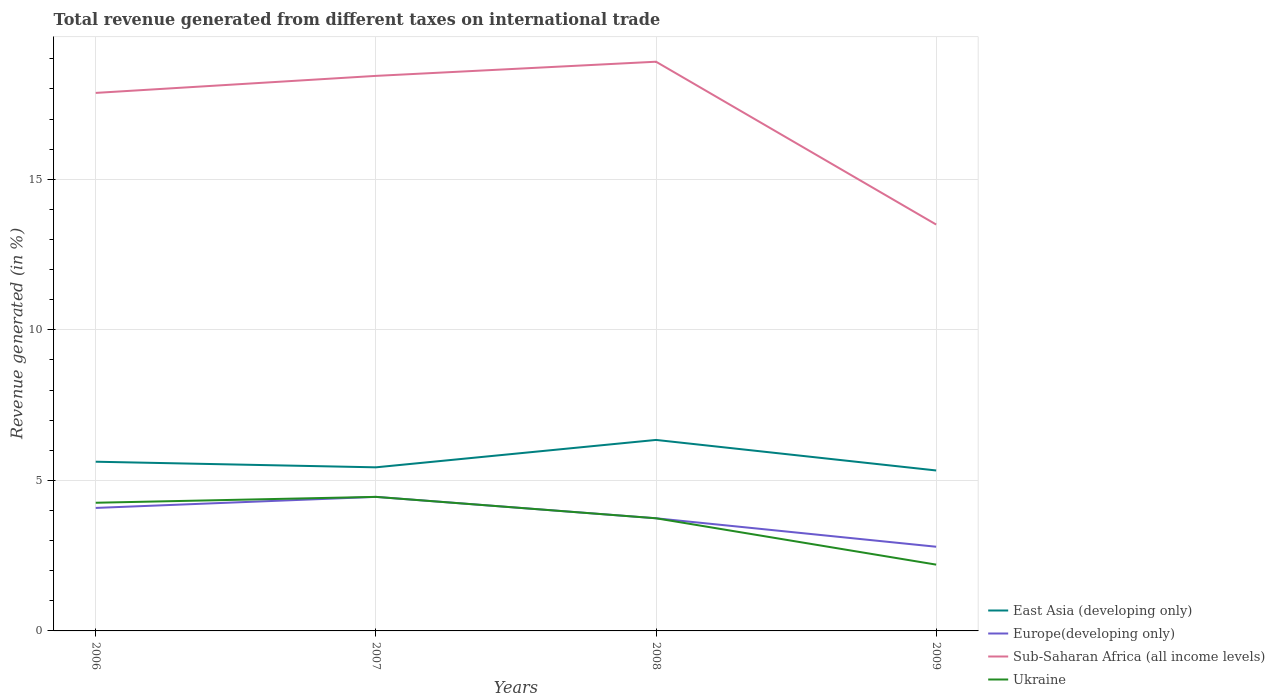Does the line corresponding to Europe(developing only) intersect with the line corresponding to Sub-Saharan Africa (all income levels)?
Ensure brevity in your answer.  No. Is the number of lines equal to the number of legend labels?
Your answer should be very brief. Yes. Across all years, what is the maximum total revenue generated in Ukraine?
Provide a short and direct response. 2.2. In which year was the total revenue generated in Europe(developing only) maximum?
Ensure brevity in your answer.  2009. What is the total total revenue generated in East Asia (developing only) in the graph?
Your response must be concise. 0.19. What is the difference between the highest and the second highest total revenue generated in Sub-Saharan Africa (all income levels)?
Ensure brevity in your answer.  5.41. What is the difference between the highest and the lowest total revenue generated in Ukraine?
Ensure brevity in your answer.  3. Is the total revenue generated in Sub-Saharan Africa (all income levels) strictly greater than the total revenue generated in East Asia (developing only) over the years?
Make the answer very short. No. Does the graph contain grids?
Give a very brief answer. Yes. How many legend labels are there?
Provide a succinct answer. 4. How are the legend labels stacked?
Offer a terse response. Vertical. What is the title of the graph?
Provide a short and direct response. Total revenue generated from different taxes on international trade. What is the label or title of the X-axis?
Keep it short and to the point. Years. What is the label or title of the Y-axis?
Offer a terse response. Revenue generated (in %). What is the Revenue generated (in %) of East Asia (developing only) in 2006?
Your answer should be very brief. 5.62. What is the Revenue generated (in %) of Europe(developing only) in 2006?
Provide a short and direct response. 4.08. What is the Revenue generated (in %) in Sub-Saharan Africa (all income levels) in 2006?
Ensure brevity in your answer.  17.87. What is the Revenue generated (in %) in Ukraine in 2006?
Offer a terse response. 4.26. What is the Revenue generated (in %) in East Asia (developing only) in 2007?
Ensure brevity in your answer.  5.43. What is the Revenue generated (in %) of Europe(developing only) in 2007?
Keep it short and to the point. 4.45. What is the Revenue generated (in %) of Sub-Saharan Africa (all income levels) in 2007?
Your response must be concise. 18.43. What is the Revenue generated (in %) of Ukraine in 2007?
Give a very brief answer. 4.45. What is the Revenue generated (in %) in East Asia (developing only) in 2008?
Make the answer very short. 6.34. What is the Revenue generated (in %) of Europe(developing only) in 2008?
Give a very brief answer. 3.74. What is the Revenue generated (in %) of Sub-Saharan Africa (all income levels) in 2008?
Keep it short and to the point. 18.9. What is the Revenue generated (in %) in Ukraine in 2008?
Offer a terse response. 3.74. What is the Revenue generated (in %) in East Asia (developing only) in 2009?
Provide a short and direct response. 5.33. What is the Revenue generated (in %) of Europe(developing only) in 2009?
Your answer should be compact. 2.8. What is the Revenue generated (in %) in Sub-Saharan Africa (all income levels) in 2009?
Keep it short and to the point. 13.5. What is the Revenue generated (in %) of Ukraine in 2009?
Your response must be concise. 2.2. Across all years, what is the maximum Revenue generated (in %) of East Asia (developing only)?
Ensure brevity in your answer.  6.34. Across all years, what is the maximum Revenue generated (in %) of Europe(developing only)?
Offer a terse response. 4.45. Across all years, what is the maximum Revenue generated (in %) of Sub-Saharan Africa (all income levels)?
Make the answer very short. 18.9. Across all years, what is the maximum Revenue generated (in %) of Ukraine?
Your answer should be very brief. 4.45. Across all years, what is the minimum Revenue generated (in %) in East Asia (developing only)?
Ensure brevity in your answer.  5.33. Across all years, what is the minimum Revenue generated (in %) of Europe(developing only)?
Offer a very short reply. 2.8. Across all years, what is the minimum Revenue generated (in %) of Sub-Saharan Africa (all income levels)?
Provide a succinct answer. 13.5. Across all years, what is the minimum Revenue generated (in %) of Ukraine?
Provide a short and direct response. 2.2. What is the total Revenue generated (in %) of East Asia (developing only) in the graph?
Your answer should be compact. 22.72. What is the total Revenue generated (in %) of Europe(developing only) in the graph?
Offer a very short reply. 15.07. What is the total Revenue generated (in %) in Sub-Saharan Africa (all income levels) in the graph?
Provide a succinct answer. 68.7. What is the total Revenue generated (in %) in Ukraine in the graph?
Keep it short and to the point. 14.65. What is the difference between the Revenue generated (in %) of East Asia (developing only) in 2006 and that in 2007?
Make the answer very short. 0.19. What is the difference between the Revenue generated (in %) of Europe(developing only) in 2006 and that in 2007?
Your response must be concise. -0.37. What is the difference between the Revenue generated (in %) of Sub-Saharan Africa (all income levels) in 2006 and that in 2007?
Your response must be concise. -0.57. What is the difference between the Revenue generated (in %) in Ukraine in 2006 and that in 2007?
Your answer should be very brief. -0.2. What is the difference between the Revenue generated (in %) in East Asia (developing only) in 2006 and that in 2008?
Keep it short and to the point. -0.72. What is the difference between the Revenue generated (in %) of Europe(developing only) in 2006 and that in 2008?
Offer a very short reply. 0.34. What is the difference between the Revenue generated (in %) in Sub-Saharan Africa (all income levels) in 2006 and that in 2008?
Offer a terse response. -1.04. What is the difference between the Revenue generated (in %) of Ukraine in 2006 and that in 2008?
Offer a terse response. 0.52. What is the difference between the Revenue generated (in %) in East Asia (developing only) in 2006 and that in 2009?
Your response must be concise. 0.29. What is the difference between the Revenue generated (in %) in Europe(developing only) in 2006 and that in 2009?
Keep it short and to the point. 1.29. What is the difference between the Revenue generated (in %) of Sub-Saharan Africa (all income levels) in 2006 and that in 2009?
Offer a very short reply. 4.37. What is the difference between the Revenue generated (in %) of Ukraine in 2006 and that in 2009?
Make the answer very short. 2.06. What is the difference between the Revenue generated (in %) of East Asia (developing only) in 2007 and that in 2008?
Your answer should be very brief. -0.91. What is the difference between the Revenue generated (in %) in Europe(developing only) in 2007 and that in 2008?
Your answer should be compact. 0.71. What is the difference between the Revenue generated (in %) of Sub-Saharan Africa (all income levels) in 2007 and that in 2008?
Your answer should be compact. -0.47. What is the difference between the Revenue generated (in %) in Ukraine in 2007 and that in 2008?
Your answer should be very brief. 0.71. What is the difference between the Revenue generated (in %) of East Asia (developing only) in 2007 and that in 2009?
Make the answer very short. 0.1. What is the difference between the Revenue generated (in %) in Europe(developing only) in 2007 and that in 2009?
Keep it short and to the point. 1.66. What is the difference between the Revenue generated (in %) of Sub-Saharan Africa (all income levels) in 2007 and that in 2009?
Ensure brevity in your answer.  4.94. What is the difference between the Revenue generated (in %) of Ukraine in 2007 and that in 2009?
Ensure brevity in your answer.  2.25. What is the difference between the Revenue generated (in %) of Europe(developing only) in 2008 and that in 2009?
Offer a very short reply. 0.95. What is the difference between the Revenue generated (in %) in Sub-Saharan Africa (all income levels) in 2008 and that in 2009?
Give a very brief answer. 5.41. What is the difference between the Revenue generated (in %) in Ukraine in 2008 and that in 2009?
Your answer should be compact. 1.54. What is the difference between the Revenue generated (in %) of East Asia (developing only) in 2006 and the Revenue generated (in %) of Europe(developing only) in 2007?
Offer a very short reply. 1.17. What is the difference between the Revenue generated (in %) in East Asia (developing only) in 2006 and the Revenue generated (in %) in Sub-Saharan Africa (all income levels) in 2007?
Your response must be concise. -12.81. What is the difference between the Revenue generated (in %) in East Asia (developing only) in 2006 and the Revenue generated (in %) in Ukraine in 2007?
Your response must be concise. 1.17. What is the difference between the Revenue generated (in %) of Europe(developing only) in 2006 and the Revenue generated (in %) of Sub-Saharan Africa (all income levels) in 2007?
Give a very brief answer. -14.35. What is the difference between the Revenue generated (in %) in Europe(developing only) in 2006 and the Revenue generated (in %) in Ukraine in 2007?
Your response must be concise. -0.37. What is the difference between the Revenue generated (in %) of Sub-Saharan Africa (all income levels) in 2006 and the Revenue generated (in %) of Ukraine in 2007?
Make the answer very short. 13.42. What is the difference between the Revenue generated (in %) of East Asia (developing only) in 2006 and the Revenue generated (in %) of Europe(developing only) in 2008?
Ensure brevity in your answer.  1.88. What is the difference between the Revenue generated (in %) in East Asia (developing only) in 2006 and the Revenue generated (in %) in Sub-Saharan Africa (all income levels) in 2008?
Keep it short and to the point. -13.28. What is the difference between the Revenue generated (in %) in East Asia (developing only) in 2006 and the Revenue generated (in %) in Ukraine in 2008?
Your response must be concise. 1.88. What is the difference between the Revenue generated (in %) in Europe(developing only) in 2006 and the Revenue generated (in %) in Sub-Saharan Africa (all income levels) in 2008?
Provide a short and direct response. -14.82. What is the difference between the Revenue generated (in %) in Europe(developing only) in 2006 and the Revenue generated (in %) in Ukraine in 2008?
Ensure brevity in your answer.  0.34. What is the difference between the Revenue generated (in %) of Sub-Saharan Africa (all income levels) in 2006 and the Revenue generated (in %) of Ukraine in 2008?
Your answer should be very brief. 14.13. What is the difference between the Revenue generated (in %) of East Asia (developing only) in 2006 and the Revenue generated (in %) of Europe(developing only) in 2009?
Your response must be concise. 2.82. What is the difference between the Revenue generated (in %) in East Asia (developing only) in 2006 and the Revenue generated (in %) in Sub-Saharan Africa (all income levels) in 2009?
Provide a succinct answer. -7.88. What is the difference between the Revenue generated (in %) in East Asia (developing only) in 2006 and the Revenue generated (in %) in Ukraine in 2009?
Provide a succinct answer. 3.42. What is the difference between the Revenue generated (in %) of Europe(developing only) in 2006 and the Revenue generated (in %) of Sub-Saharan Africa (all income levels) in 2009?
Give a very brief answer. -9.41. What is the difference between the Revenue generated (in %) in Europe(developing only) in 2006 and the Revenue generated (in %) in Ukraine in 2009?
Your answer should be very brief. 1.88. What is the difference between the Revenue generated (in %) of Sub-Saharan Africa (all income levels) in 2006 and the Revenue generated (in %) of Ukraine in 2009?
Ensure brevity in your answer.  15.67. What is the difference between the Revenue generated (in %) in East Asia (developing only) in 2007 and the Revenue generated (in %) in Europe(developing only) in 2008?
Provide a succinct answer. 1.69. What is the difference between the Revenue generated (in %) in East Asia (developing only) in 2007 and the Revenue generated (in %) in Sub-Saharan Africa (all income levels) in 2008?
Your answer should be compact. -13.47. What is the difference between the Revenue generated (in %) of East Asia (developing only) in 2007 and the Revenue generated (in %) of Ukraine in 2008?
Offer a terse response. 1.69. What is the difference between the Revenue generated (in %) in Europe(developing only) in 2007 and the Revenue generated (in %) in Sub-Saharan Africa (all income levels) in 2008?
Offer a very short reply. -14.45. What is the difference between the Revenue generated (in %) in Europe(developing only) in 2007 and the Revenue generated (in %) in Ukraine in 2008?
Ensure brevity in your answer.  0.71. What is the difference between the Revenue generated (in %) of Sub-Saharan Africa (all income levels) in 2007 and the Revenue generated (in %) of Ukraine in 2008?
Your response must be concise. 14.69. What is the difference between the Revenue generated (in %) in East Asia (developing only) in 2007 and the Revenue generated (in %) in Europe(developing only) in 2009?
Your response must be concise. 2.64. What is the difference between the Revenue generated (in %) in East Asia (developing only) in 2007 and the Revenue generated (in %) in Sub-Saharan Africa (all income levels) in 2009?
Offer a terse response. -8.06. What is the difference between the Revenue generated (in %) of East Asia (developing only) in 2007 and the Revenue generated (in %) of Ukraine in 2009?
Make the answer very short. 3.23. What is the difference between the Revenue generated (in %) of Europe(developing only) in 2007 and the Revenue generated (in %) of Sub-Saharan Africa (all income levels) in 2009?
Make the answer very short. -9.04. What is the difference between the Revenue generated (in %) of Europe(developing only) in 2007 and the Revenue generated (in %) of Ukraine in 2009?
Your answer should be compact. 2.25. What is the difference between the Revenue generated (in %) of Sub-Saharan Africa (all income levels) in 2007 and the Revenue generated (in %) of Ukraine in 2009?
Give a very brief answer. 16.23. What is the difference between the Revenue generated (in %) in East Asia (developing only) in 2008 and the Revenue generated (in %) in Europe(developing only) in 2009?
Keep it short and to the point. 3.55. What is the difference between the Revenue generated (in %) in East Asia (developing only) in 2008 and the Revenue generated (in %) in Sub-Saharan Africa (all income levels) in 2009?
Keep it short and to the point. -7.15. What is the difference between the Revenue generated (in %) of East Asia (developing only) in 2008 and the Revenue generated (in %) of Ukraine in 2009?
Ensure brevity in your answer.  4.14. What is the difference between the Revenue generated (in %) in Europe(developing only) in 2008 and the Revenue generated (in %) in Sub-Saharan Africa (all income levels) in 2009?
Make the answer very short. -9.75. What is the difference between the Revenue generated (in %) in Europe(developing only) in 2008 and the Revenue generated (in %) in Ukraine in 2009?
Ensure brevity in your answer.  1.54. What is the difference between the Revenue generated (in %) of Sub-Saharan Africa (all income levels) in 2008 and the Revenue generated (in %) of Ukraine in 2009?
Keep it short and to the point. 16.7. What is the average Revenue generated (in %) in East Asia (developing only) per year?
Provide a succinct answer. 5.68. What is the average Revenue generated (in %) of Europe(developing only) per year?
Provide a short and direct response. 3.77. What is the average Revenue generated (in %) of Sub-Saharan Africa (all income levels) per year?
Make the answer very short. 17.17. What is the average Revenue generated (in %) of Ukraine per year?
Keep it short and to the point. 3.66. In the year 2006, what is the difference between the Revenue generated (in %) of East Asia (developing only) and Revenue generated (in %) of Europe(developing only)?
Give a very brief answer. 1.53. In the year 2006, what is the difference between the Revenue generated (in %) of East Asia (developing only) and Revenue generated (in %) of Sub-Saharan Africa (all income levels)?
Keep it short and to the point. -12.25. In the year 2006, what is the difference between the Revenue generated (in %) of East Asia (developing only) and Revenue generated (in %) of Ukraine?
Make the answer very short. 1.36. In the year 2006, what is the difference between the Revenue generated (in %) in Europe(developing only) and Revenue generated (in %) in Sub-Saharan Africa (all income levels)?
Offer a terse response. -13.78. In the year 2006, what is the difference between the Revenue generated (in %) of Europe(developing only) and Revenue generated (in %) of Ukraine?
Offer a very short reply. -0.17. In the year 2006, what is the difference between the Revenue generated (in %) in Sub-Saharan Africa (all income levels) and Revenue generated (in %) in Ukraine?
Ensure brevity in your answer.  13.61. In the year 2007, what is the difference between the Revenue generated (in %) in East Asia (developing only) and Revenue generated (in %) in Europe(developing only)?
Provide a short and direct response. 0.98. In the year 2007, what is the difference between the Revenue generated (in %) of East Asia (developing only) and Revenue generated (in %) of Sub-Saharan Africa (all income levels)?
Provide a short and direct response. -13. In the year 2007, what is the difference between the Revenue generated (in %) of East Asia (developing only) and Revenue generated (in %) of Ukraine?
Ensure brevity in your answer.  0.98. In the year 2007, what is the difference between the Revenue generated (in %) in Europe(developing only) and Revenue generated (in %) in Sub-Saharan Africa (all income levels)?
Your answer should be very brief. -13.98. In the year 2007, what is the difference between the Revenue generated (in %) of Sub-Saharan Africa (all income levels) and Revenue generated (in %) of Ukraine?
Provide a succinct answer. 13.98. In the year 2008, what is the difference between the Revenue generated (in %) of East Asia (developing only) and Revenue generated (in %) of Europe(developing only)?
Your answer should be compact. 2.6. In the year 2008, what is the difference between the Revenue generated (in %) of East Asia (developing only) and Revenue generated (in %) of Sub-Saharan Africa (all income levels)?
Your answer should be compact. -12.56. In the year 2008, what is the difference between the Revenue generated (in %) in East Asia (developing only) and Revenue generated (in %) in Ukraine?
Your answer should be very brief. 2.6. In the year 2008, what is the difference between the Revenue generated (in %) in Europe(developing only) and Revenue generated (in %) in Sub-Saharan Africa (all income levels)?
Your response must be concise. -15.16. In the year 2008, what is the difference between the Revenue generated (in %) of Europe(developing only) and Revenue generated (in %) of Ukraine?
Keep it short and to the point. 0. In the year 2008, what is the difference between the Revenue generated (in %) of Sub-Saharan Africa (all income levels) and Revenue generated (in %) of Ukraine?
Your answer should be compact. 15.16. In the year 2009, what is the difference between the Revenue generated (in %) in East Asia (developing only) and Revenue generated (in %) in Europe(developing only)?
Provide a short and direct response. 2.53. In the year 2009, what is the difference between the Revenue generated (in %) of East Asia (developing only) and Revenue generated (in %) of Sub-Saharan Africa (all income levels)?
Keep it short and to the point. -8.17. In the year 2009, what is the difference between the Revenue generated (in %) in East Asia (developing only) and Revenue generated (in %) in Ukraine?
Make the answer very short. 3.13. In the year 2009, what is the difference between the Revenue generated (in %) of Europe(developing only) and Revenue generated (in %) of Ukraine?
Your answer should be very brief. 0.59. In the year 2009, what is the difference between the Revenue generated (in %) in Sub-Saharan Africa (all income levels) and Revenue generated (in %) in Ukraine?
Ensure brevity in your answer.  11.29. What is the ratio of the Revenue generated (in %) of East Asia (developing only) in 2006 to that in 2007?
Your response must be concise. 1.03. What is the ratio of the Revenue generated (in %) of Europe(developing only) in 2006 to that in 2007?
Give a very brief answer. 0.92. What is the ratio of the Revenue generated (in %) in Sub-Saharan Africa (all income levels) in 2006 to that in 2007?
Keep it short and to the point. 0.97. What is the ratio of the Revenue generated (in %) of Ukraine in 2006 to that in 2007?
Provide a short and direct response. 0.96. What is the ratio of the Revenue generated (in %) of East Asia (developing only) in 2006 to that in 2008?
Provide a short and direct response. 0.89. What is the ratio of the Revenue generated (in %) of Europe(developing only) in 2006 to that in 2008?
Your response must be concise. 1.09. What is the ratio of the Revenue generated (in %) of Sub-Saharan Africa (all income levels) in 2006 to that in 2008?
Make the answer very short. 0.95. What is the ratio of the Revenue generated (in %) in Ukraine in 2006 to that in 2008?
Give a very brief answer. 1.14. What is the ratio of the Revenue generated (in %) of East Asia (developing only) in 2006 to that in 2009?
Give a very brief answer. 1.05. What is the ratio of the Revenue generated (in %) in Europe(developing only) in 2006 to that in 2009?
Offer a very short reply. 1.46. What is the ratio of the Revenue generated (in %) in Sub-Saharan Africa (all income levels) in 2006 to that in 2009?
Keep it short and to the point. 1.32. What is the ratio of the Revenue generated (in %) in Ukraine in 2006 to that in 2009?
Provide a succinct answer. 1.93. What is the ratio of the Revenue generated (in %) in East Asia (developing only) in 2007 to that in 2008?
Make the answer very short. 0.86. What is the ratio of the Revenue generated (in %) of Europe(developing only) in 2007 to that in 2008?
Keep it short and to the point. 1.19. What is the ratio of the Revenue generated (in %) in Sub-Saharan Africa (all income levels) in 2007 to that in 2008?
Your answer should be very brief. 0.98. What is the ratio of the Revenue generated (in %) of Ukraine in 2007 to that in 2008?
Your answer should be very brief. 1.19. What is the ratio of the Revenue generated (in %) of East Asia (developing only) in 2007 to that in 2009?
Provide a succinct answer. 1.02. What is the ratio of the Revenue generated (in %) in Europe(developing only) in 2007 to that in 2009?
Offer a terse response. 1.59. What is the ratio of the Revenue generated (in %) in Sub-Saharan Africa (all income levels) in 2007 to that in 2009?
Your answer should be compact. 1.37. What is the ratio of the Revenue generated (in %) of Ukraine in 2007 to that in 2009?
Give a very brief answer. 2.02. What is the ratio of the Revenue generated (in %) of East Asia (developing only) in 2008 to that in 2009?
Provide a succinct answer. 1.19. What is the ratio of the Revenue generated (in %) of Europe(developing only) in 2008 to that in 2009?
Keep it short and to the point. 1.34. What is the ratio of the Revenue generated (in %) in Sub-Saharan Africa (all income levels) in 2008 to that in 2009?
Your answer should be compact. 1.4. What is the ratio of the Revenue generated (in %) in Ukraine in 2008 to that in 2009?
Ensure brevity in your answer.  1.7. What is the difference between the highest and the second highest Revenue generated (in %) in East Asia (developing only)?
Your answer should be compact. 0.72. What is the difference between the highest and the second highest Revenue generated (in %) in Europe(developing only)?
Keep it short and to the point. 0.37. What is the difference between the highest and the second highest Revenue generated (in %) in Sub-Saharan Africa (all income levels)?
Offer a very short reply. 0.47. What is the difference between the highest and the second highest Revenue generated (in %) in Ukraine?
Give a very brief answer. 0.2. What is the difference between the highest and the lowest Revenue generated (in %) of East Asia (developing only)?
Provide a succinct answer. 1.01. What is the difference between the highest and the lowest Revenue generated (in %) of Europe(developing only)?
Provide a short and direct response. 1.66. What is the difference between the highest and the lowest Revenue generated (in %) in Sub-Saharan Africa (all income levels)?
Your answer should be very brief. 5.41. What is the difference between the highest and the lowest Revenue generated (in %) in Ukraine?
Keep it short and to the point. 2.25. 